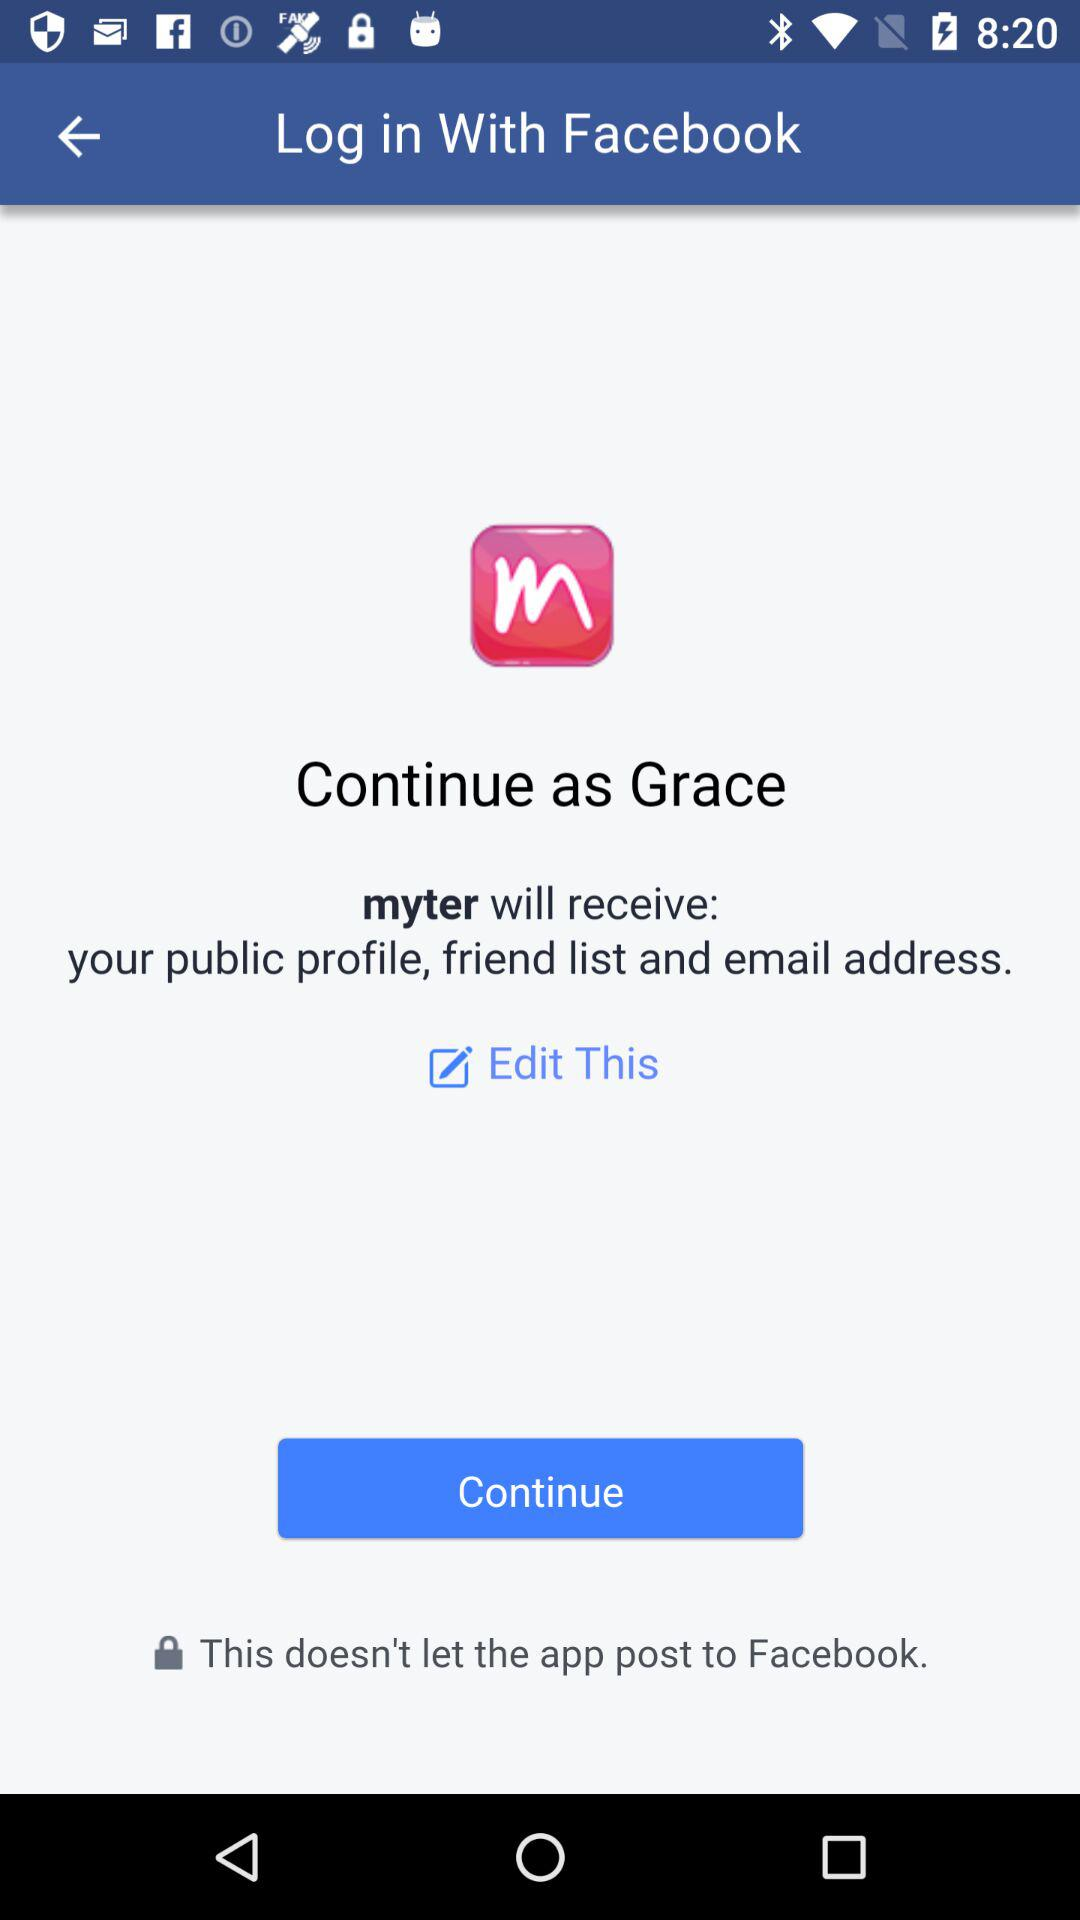Which information will "myter" receive? "myter" will receive the public profile, friend list and email address. 